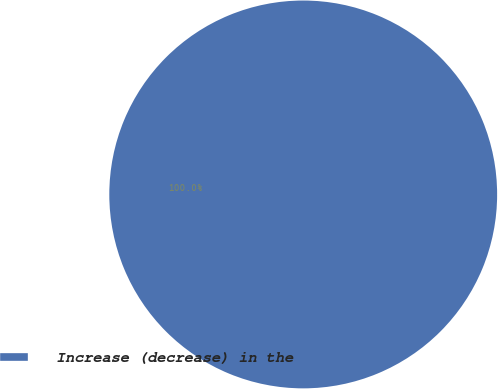<chart> <loc_0><loc_0><loc_500><loc_500><pie_chart><fcel>Increase (decrease) in the<nl><fcel>100.0%<nl></chart> 